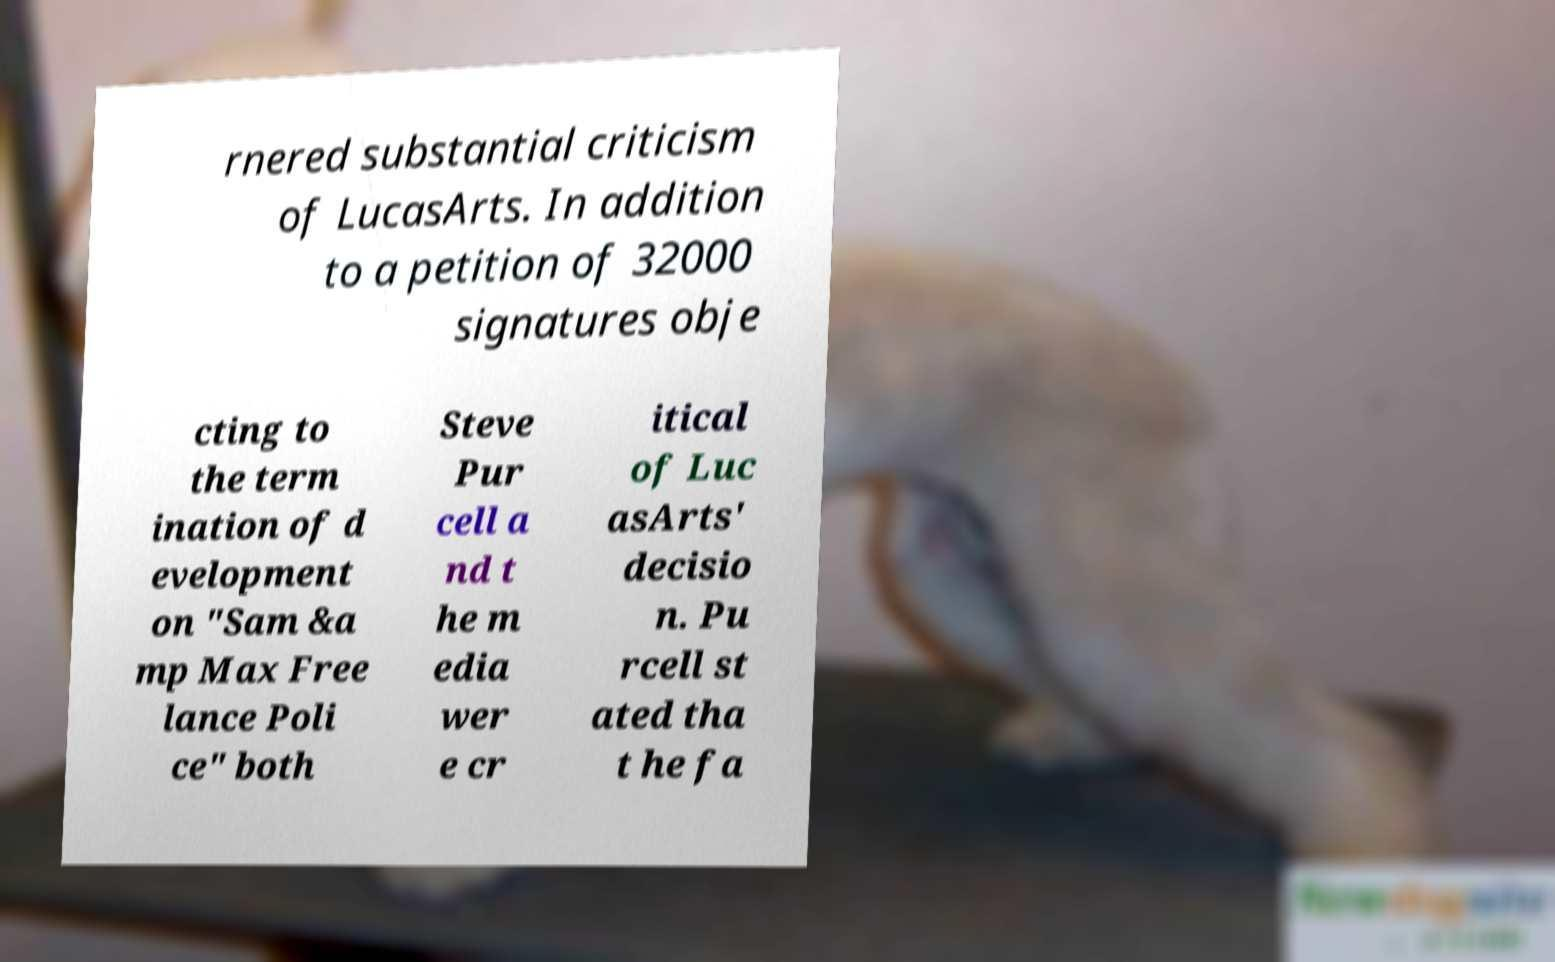Could you assist in decoding the text presented in this image and type it out clearly? rnered substantial criticism of LucasArts. In addition to a petition of 32000 signatures obje cting to the term ination of d evelopment on "Sam &a mp Max Free lance Poli ce" both Steve Pur cell a nd t he m edia wer e cr itical of Luc asArts' decisio n. Pu rcell st ated tha t he fa 